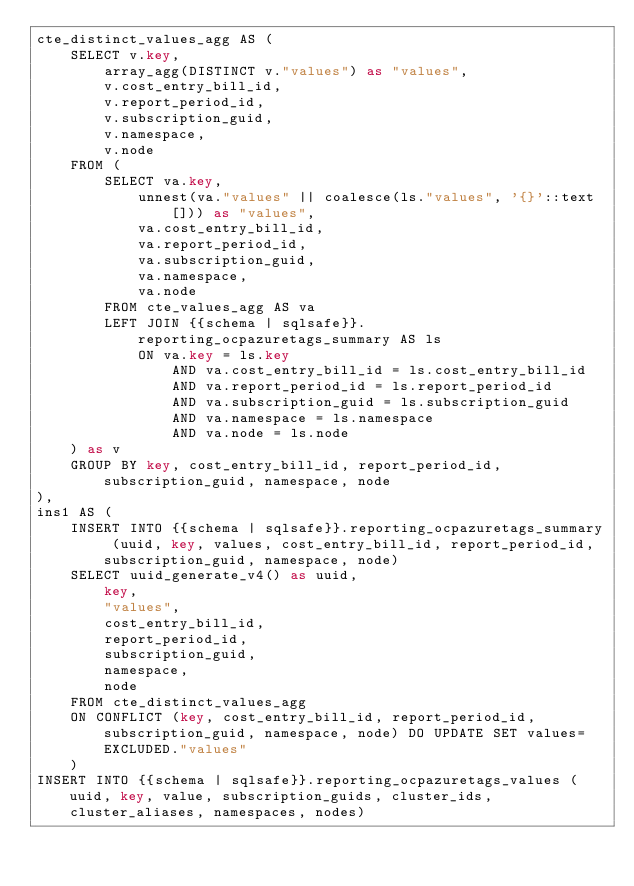Convert code to text. <code><loc_0><loc_0><loc_500><loc_500><_SQL_>cte_distinct_values_agg AS (
    SELECT v.key,
        array_agg(DISTINCT v."values") as "values",
        v.cost_entry_bill_id,
        v.report_period_id,
        v.subscription_guid,
        v.namespace,
        v.node
    FROM (
        SELECT va.key,
            unnest(va."values" || coalesce(ls."values", '{}'::text[])) as "values",
            va.cost_entry_bill_id,
            va.report_period_id,
            va.subscription_guid,
            va.namespace,
            va.node
        FROM cte_values_agg AS va
        LEFT JOIN {{schema | sqlsafe}}.reporting_ocpazuretags_summary AS ls
            ON va.key = ls.key
                AND va.cost_entry_bill_id = ls.cost_entry_bill_id
                AND va.report_period_id = ls.report_period_id
                AND va.subscription_guid = ls.subscription_guid
                AND va.namespace = ls.namespace
                AND va.node = ls.node
    ) as v
    GROUP BY key, cost_entry_bill_id, report_period_id, subscription_guid, namespace, node
),
ins1 AS (
    INSERT INTO {{schema | sqlsafe}}.reporting_ocpazuretags_summary (uuid, key, values, cost_entry_bill_id, report_period_id, subscription_guid, namespace, node)
    SELECT uuid_generate_v4() as uuid,
        key,
        "values",
        cost_entry_bill_id,
        report_period_id,
        subscription_guid,
        namespace,
        node
    FROM cte_distinct_values_agg
    ON CONFLICT (key, cost_entry_bill_id, report_period_id, subscription_guid, namespace, node) DO UPDATE SET values=EXCLUDED."values"
    )
INSERT INTO {{schema | sqlsafe}}.reporting_ocpazuretags_values (uuid, key, value, subscription_guids, cluster_ids, cluster_aliases, namespaces, nodes)</code> 